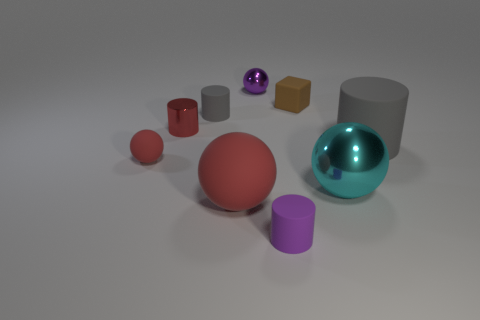There is a matte thing that is the same color as the tiny matte sphere; what shape is it?
Make the answer very short. Sphere. What is the material of the cylinder that is right of the tiny cylinder in front of the gray object that is on the right side of the big metal sphere?
Offer a terse response. Rubber. How many small things are either red metal objects or matte blocks?
Provide a short and direct response. 2. How many other things are there of the same size as the purple ball?
Make the answer very short. 5. There is a shiny object in front of the large gray cylinder; does it have the same shape as the tiny purple rubber object?
Ensure brevity in your answer.  No. There is a large thing that is the same shape as the tiny red shiny object; what color is it?
Provide a succinct answer. Gray. Is there anything else that is the same shape as the red metal thing?
Provide a short and direct response. Yes. Are there an equal number of big red balls that are right of the rubber block and brown rubber objects?
Provide a short and direct response. No. How many tiny cylinders are both behind the purple matte thing and right of the tiny red metal cylinder?
Make the answer very short. 1. What is the size of the other red thing that is the same shape as the large red rubber thing?
Provide a succinct answer. Small. 